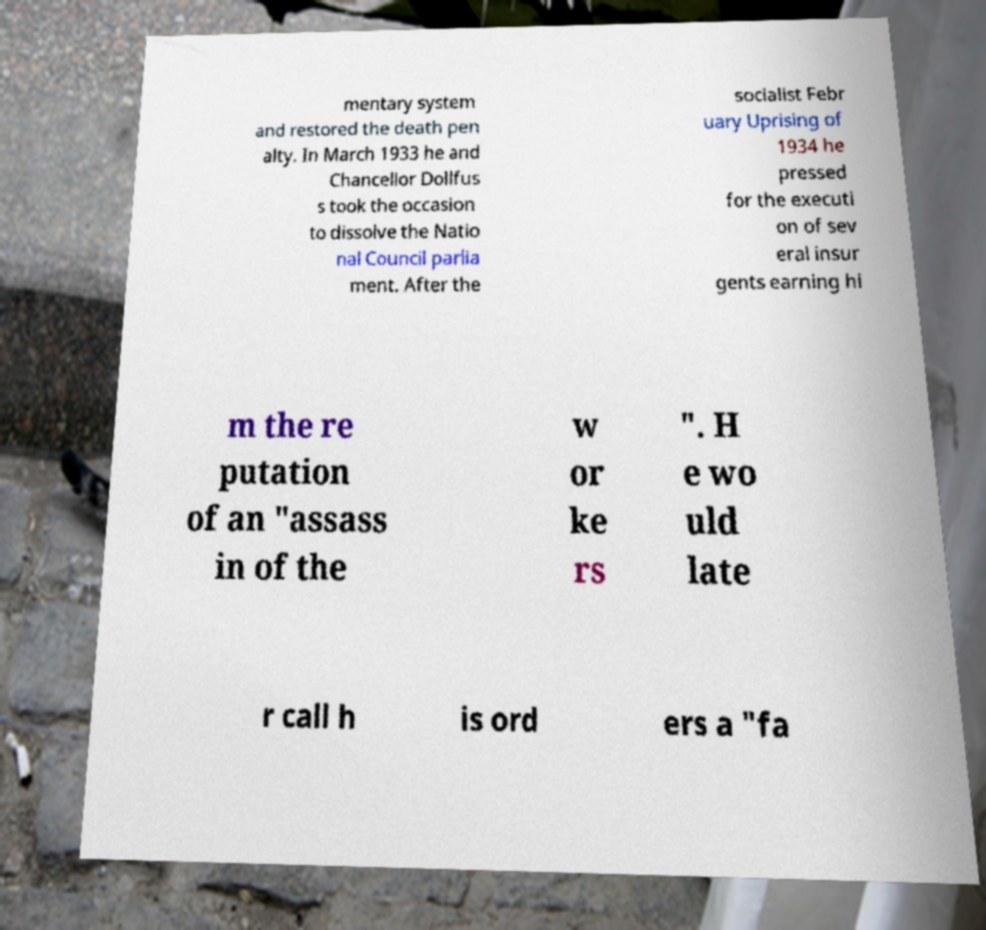Please read and relay the text visible in this image. What does it say? mentary system and restored the death pen alty. In March 1933 he and Chancellor Dollfus s took the occasion to dissolve the Natio nal Council parlia ment. After the socialist Febr uary Uprising of 1934 he pressed for the executi on of sev eral insur gents earning hi m the re putation of an "assass in of the w or ke rs ". H e wo uld late r call h is ord ers a "fa 